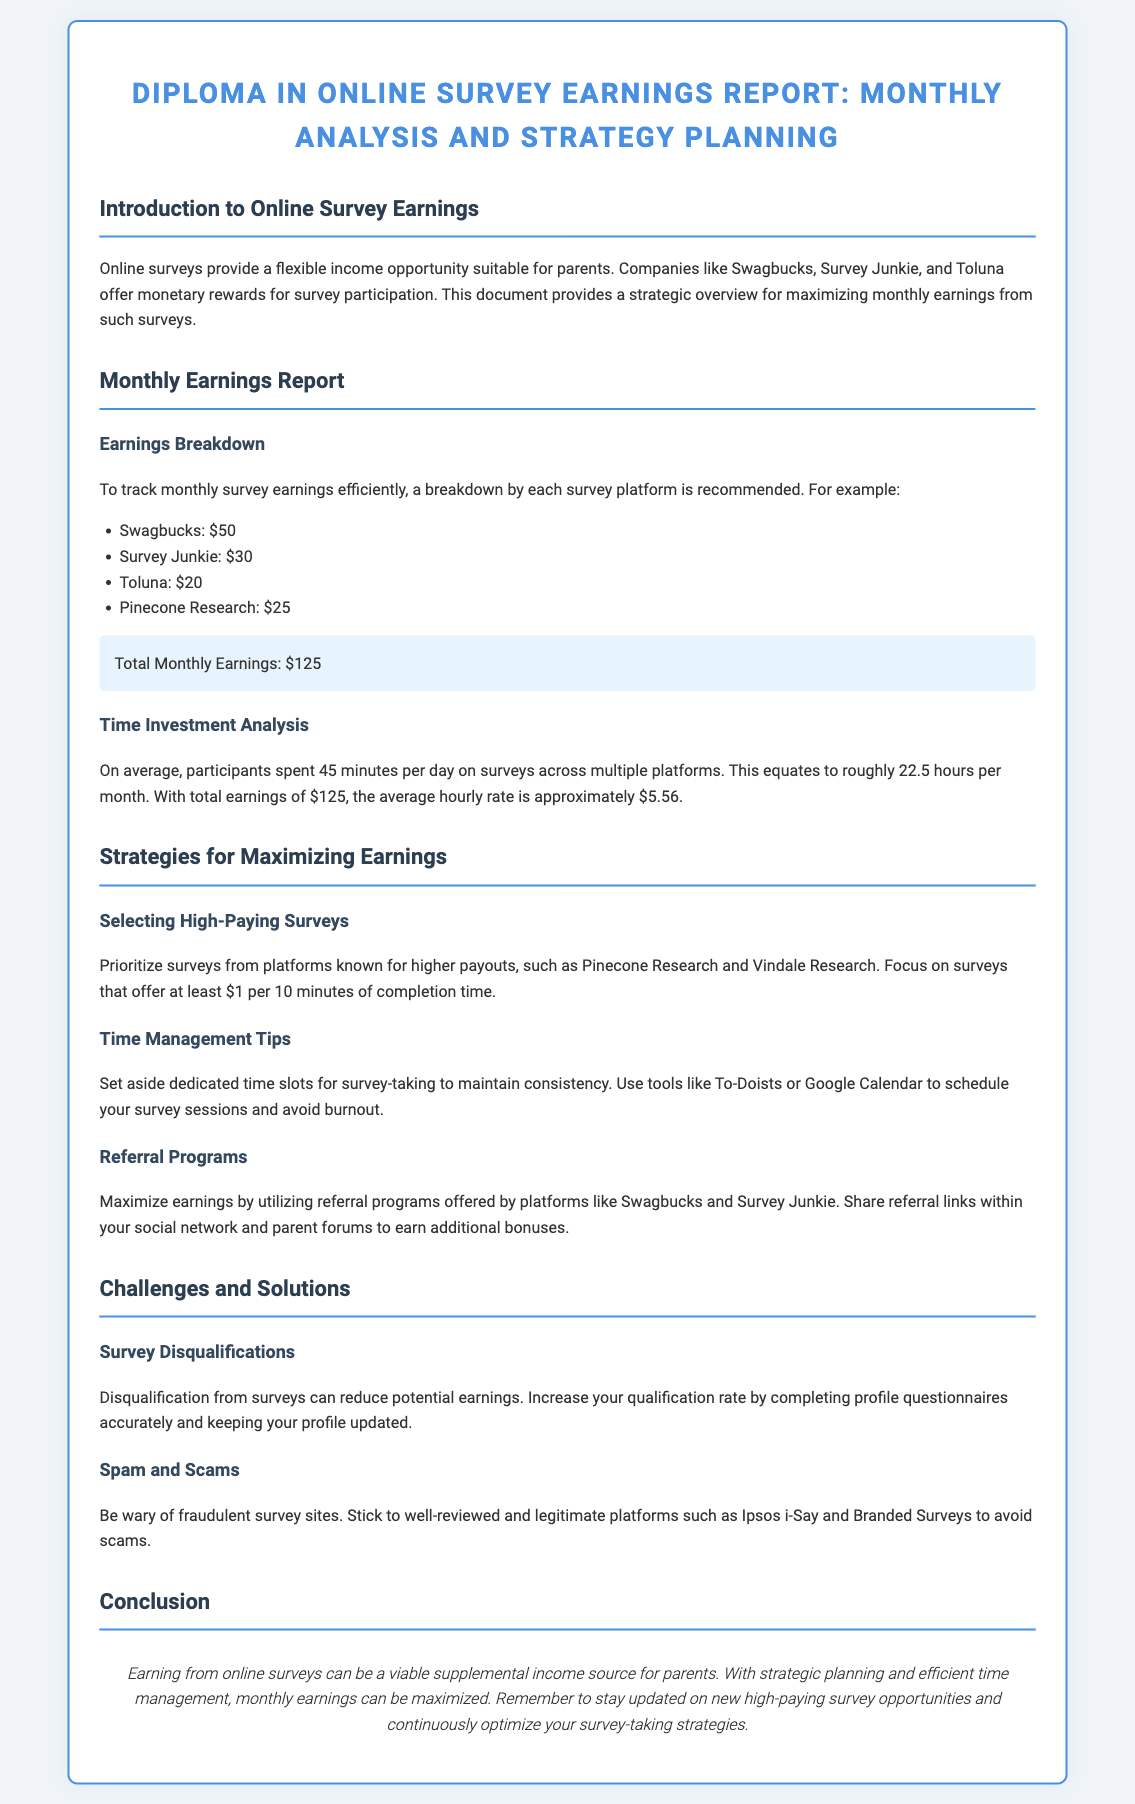What is the title of the diploma? The title of the diploma is provided at the top of the document, stating its purpose and content.
Answer: Diploma in Online Survey Earnings Report: Monthly Analysis and Strategy Planning What is the total monthly earnings reported? The document states the total monthly earnings calculated from individual platform contributions.
Answer: $125 Which platform offers the highest earnings? The breakdown of earnings by platform indicates which one has the highest return for survey participation.
Answer: Swagbucks What is the average hourly rate for surveys? The average hourly rate is calculated based on total earnings and time spent on surveys.
Answer: $5.56 What should be prioritized according to the strategies section? The strategies section advises on focusing on surveys that provide higher payout rates to maximize earnings.
Answer: High-paying surveys What time investment is suggested for survey participation? The document provides a suggested average time spent on surveys per day to help participants plan.
Answer: 45 minutes What is a common challenge when participating in online surveys? The document outlines frequent hurdles that participants may face when attempting to earn money through surveys.
Answer: Survey disqualifications Which two platforms are mentioned for referral programs? The text specifically names platforms that provide referral opportunities for extra earnings.
Answer: Swagbucks and Survey Junkie What is the recommended action to avoid survey scams? The document advises on the importance of choosing trustworthy and well-reviewed survey platforms to prevent scams.
Answer: Stick to well-reviewed platforms 